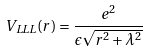Convert formula to latex. <formula><loc_0><loc_0><loc_500><loc_500>V _ { L L L } ( r ) = \frac { e ^ { 2 } } { \epsilon \sqrt { r ^ { 2 } + \lambda ^ { 2 } } }</formula> 